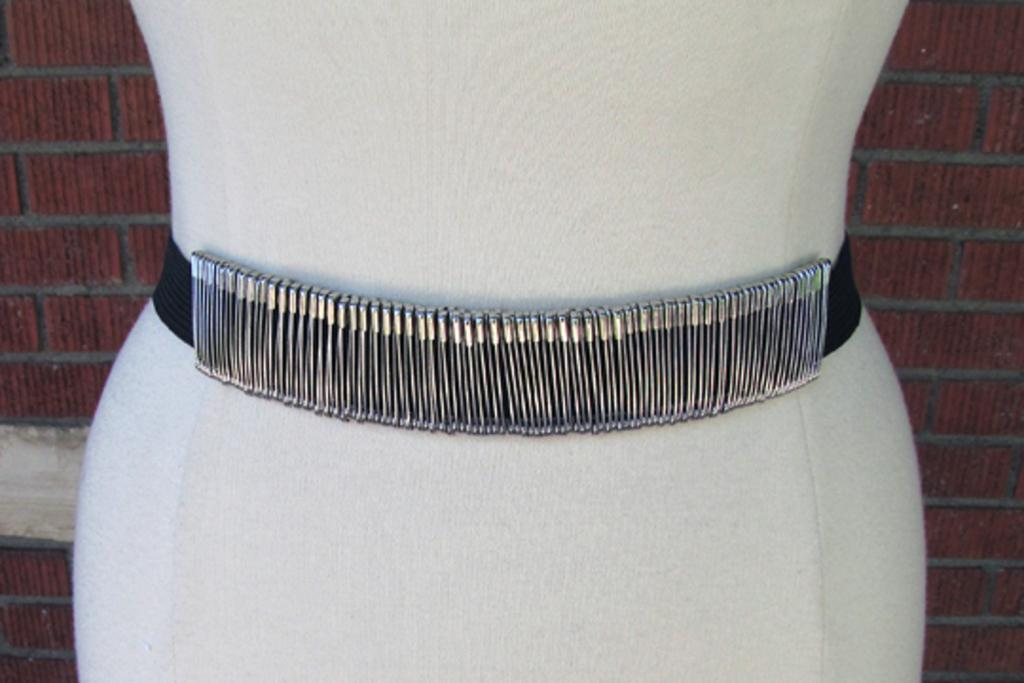What is the main subject in the image? There is a mannequin in the image. What items can be seen near the mannequin? There are safety pins in the image. What is visible in the background of the image? There is a wall in the background of the image. Are there any cobwebs visible on the mannequin in the image? There is no mention of cobwebs in the provided facts, so we cannot determine if any are present in the image. 